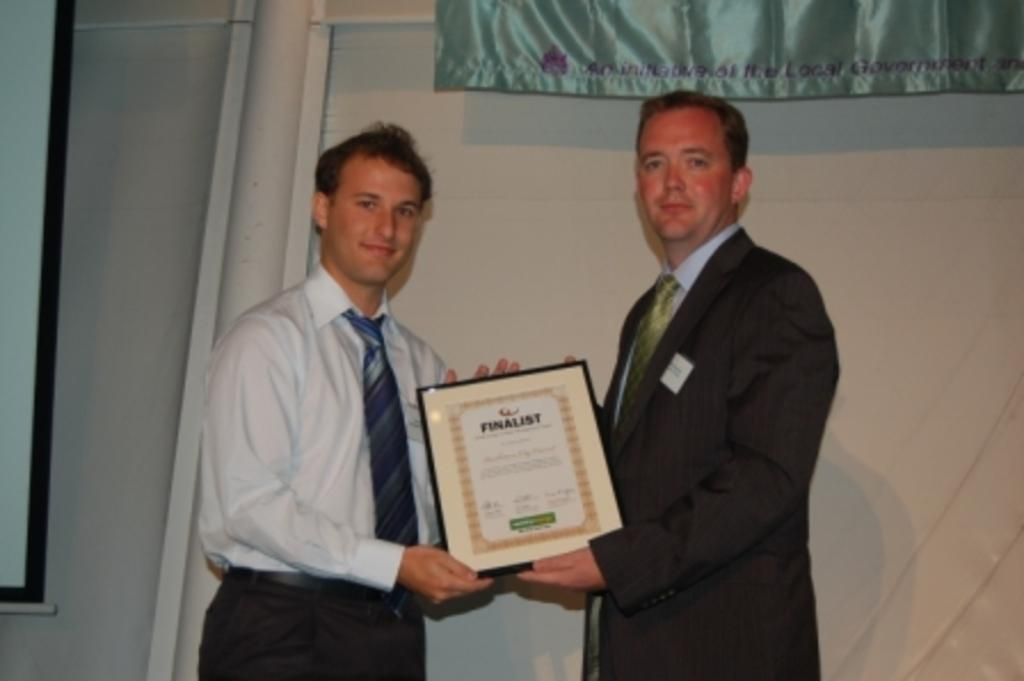How many people are in the image? There are two people in the image. What are the two people doing in the image? The two people are standing and holding an object. What can be seen in the background of the image? There is a curtain and a wall visible in the image. How many pigs can be seen swimming in the ocean in the image? There are no pigs or ocean present in the image. 